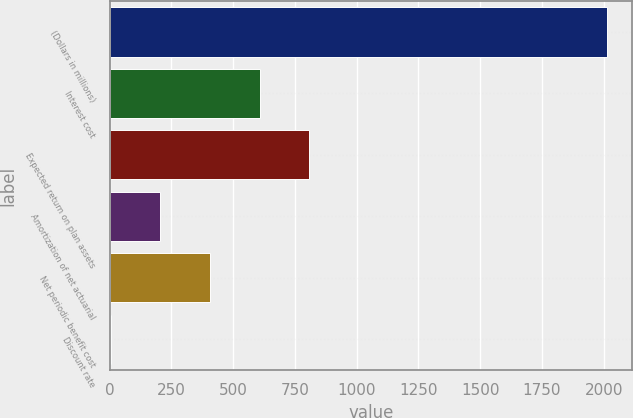Convert chart. <chart><loc_0><loc_0><loc_500><loc_500><bar_chart><fcel>(Dollars in millions)<fcel>Interest cost<fcel>Expected return on plan assets<fcel>Amortization of net actuarial<fcel>Net periodic benefit cost<fcel>Discount rate<nl><fcel>2015<fcel>606.98<fcel>808.12<fcel>204.7<fcel>405.84<fcel>3.56<nl></chart> 